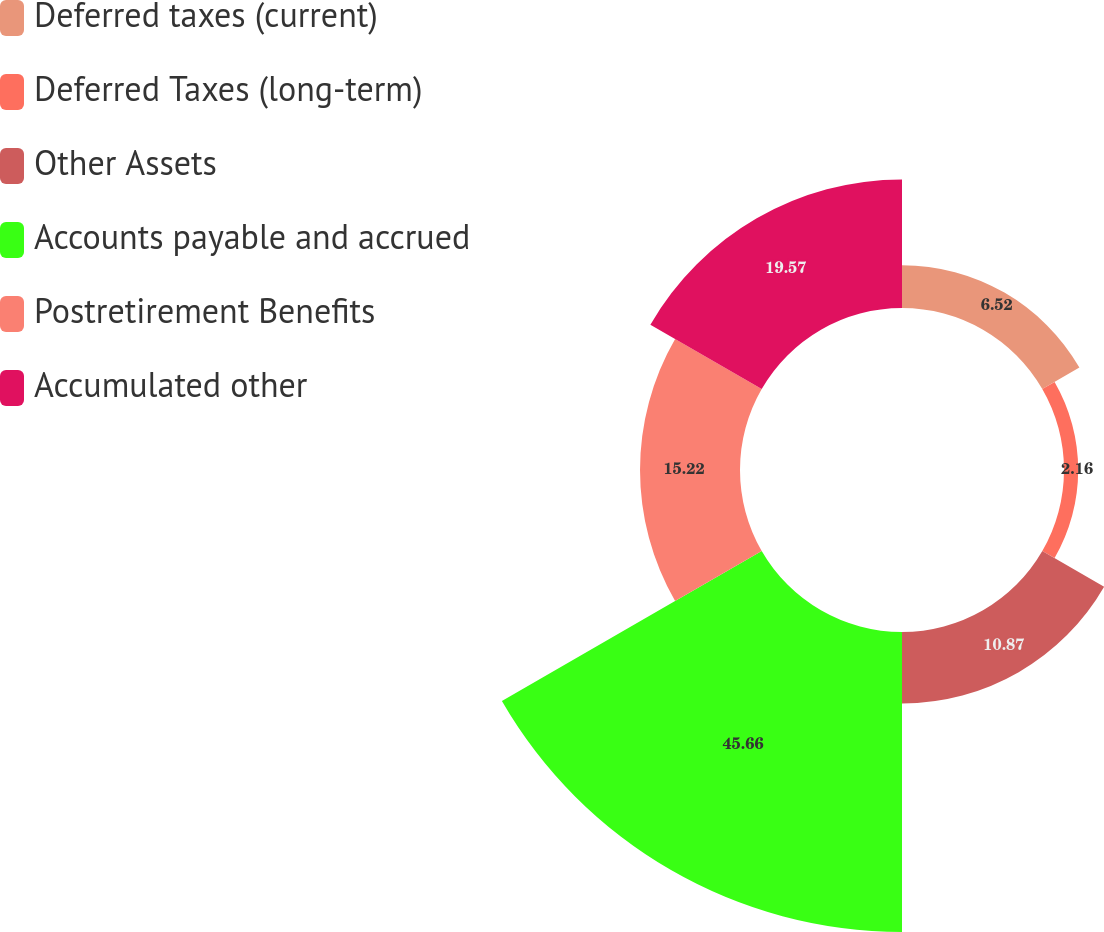Convert chart to OTSL. <chart><loc_0><loc_0><loc_500><loc_500><pie_chart><fcel>Deferred taxes (current)<fcel>Deferred Taxes (long-term)<fcel>Other Assets<fcel>Accounts payable and accrued<fcel>Postretirement Benefits<fcel>Accumulated other<nl><fcel>6.52%<fcel>2.16%<fcel>10.87%<fcel>45.67%<fcel>15.22%<fcel>19.57%<nl></chart> 